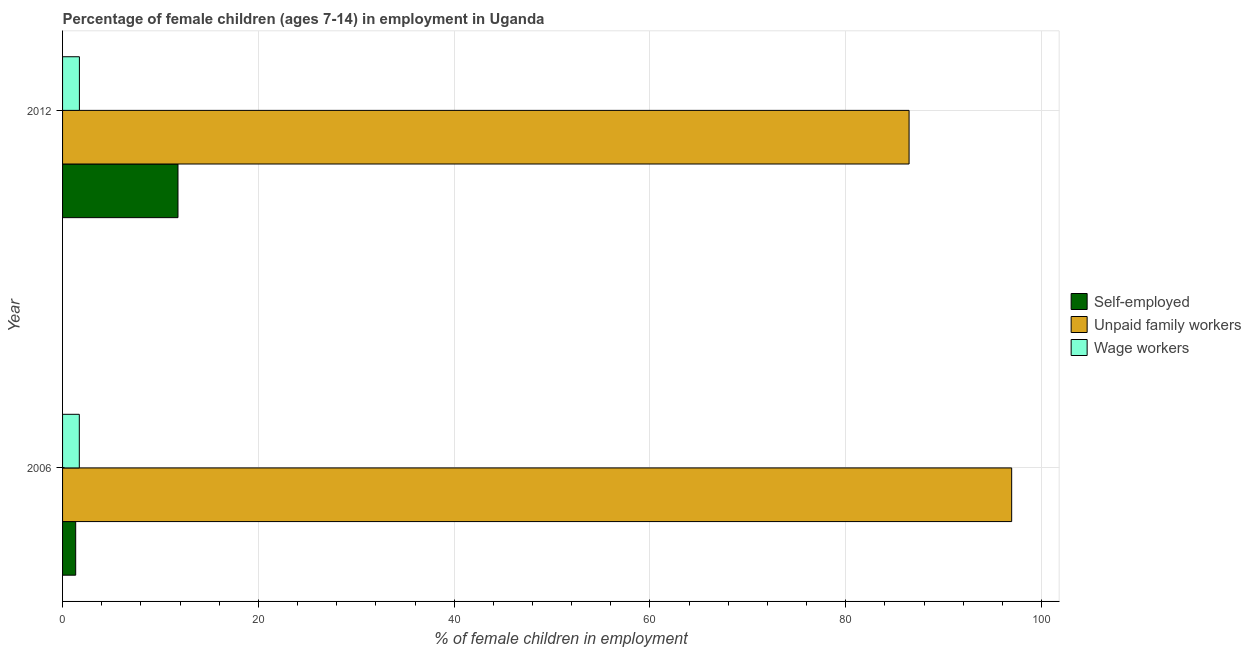Are the number of bars on each tick of the Y-axis equal?
Give a very brief answer. Yes. How many bars are there on the 1st tick from the bottom?
Offer a terse response. 3. What is the label of the 2nd group of bars from the top?
Provide a short and direct response. 2006. In how many cases, is the number of bars for a given year not equal to the number of legend labels?
Provide a short and direct response. 0. What is the percentage of children employed as wage workers in 2006?
Ensure brevity in your answer.  1.71. Across all years, what is the maximum percentage of children employed as wage workers?
Ensure brevity in your answer.  1.72. Across all years, what is the minimum percentage of children employed as wage workers?
Keep it short and to the point. 1.71. In which year was the percentage of children employed as unpaid family workers minimum?
Keep it short and to the point. 2012. What is the total percentage of self employed children in the graph?
Your answer should be very brief. 13.13. What is the difference between the percentage of children employed as unpaid family workers in 2006 and that in 2012?
Offer a terse response. 10.48. What is the difference between the percentage of children employed as unpaid family workers in 2006 and the percentage of children employed as wage workers in 2012?
Provide a succinct answer. 95.23. What is the average percentage of children employed as unpaid family workers per year?
Your answer should be compact. 91.71. In the year 2006, what is the difference between the percentage of self employed children and percentage of children employed as unpaid family workers?
Your answer should be compact. -95.61. In how many years, is the percentage of children employed as unpaid family workers greater than 4 %?
Offer a terse response. 2. What is the ratio of the percentage of self employed children in 2006 to that in 2012?
Provide a succinct answer. 0.11. What does the 1st bar from the top in 2012 represents?
Offer a terse response. Wage workers. What does the 3rd bar from the bottom in 2012 represents?
Ensure brevity in your answer.  Wage workers. Is it the case that in every year, the sum of the percentage of self employed children and percentage of children employed as unpaid family workers is greater than the percentage of children employed as wage workers?
Ensure brevity in your answer.  Yes. How many bars are there?
Provide a succinct answer. 6. Are all the bars in the graph horizontal?
Ensure brevity in your answer.  Yes. How many years are there in the graph?
Provide a succinct answer. 2. What is the difference between two consecutive major ticks on the X-axis?
Your response must be concise. 20. Are the values on the major ticks of X-axis written in scientific E-notation?
Provide a short and direct response. No. Does the graph contain grids?
Your answer should be compact. Yes. How many legend labels are there?
Your response must be concise. 3. How are the legend labels stacked?
Provide a short and direct response. Vertical. What is the title of the graph?
Offer a terse response. Percentage of female children (ages 7-14) in employment in Uganda. Does "Ages 15-64" appear as one of the legend labels in the graph?
Offer a very short reply. No. What is the label or title of the X-axis?
Your answer should be compact. % of female children in employment. What is the label or title of the Y-axis?
Give a very brief answer. Year. What is the % of female children in employment in Self-employed in 2006?
Offer a terse response. 1.34. What is the % of female children in employment of Unpaid family workers in 2006?
Give a very brief answer. 96.95. What is the % of female children in employment of Wage workers in 2006?
Make the answer very short. 1.71. What is the % of female children in employment of Self-employed in 2012?
Your response must be concise. 11.79. What is the % of female children in employment in Unpaid family workers in 2012?
Give a very brief answer. 86.47. What is the % of female children in employment in Wage workers in 2012?
Make the answer very short. 1.72. Across all years, what is the maximum % of female children in employment of Self-employed?
Offer a very short reply. 11.79. Across all years, what is the maximum % of female children in employment of Unpaid family workers?
Provide a short and direct response. 96.95. Across all years, what is the maximum % of female children in employment in Wage workers?
Make the answer very short. 1.72. Across all years, what is the minimum % of female children in employment of Self-employed?
Your answer should be very brief. 1.34. Across all years, what is the minimum % of female children in employment of Unpaid family workers?
Offer a very short reply. 86.47. Across all years, what is the minimum % of female children in employment in Wage workers?
Give a very brief answer. 1.71. What is the total % of female children in employment in Self-employed in the graph?
Your answer should be compact. 13.13. What is the total % of female children in employment in Unpaid family workers in the graph?
Offer a very short reply. 183.42. What is the total % of female children in employment in Wage workers in the graph?
Your answer should be very brief. 3.43. What is the difference between the % of female children in employment of Self-employed in 2006 and that in 2012?
Your answer should be very brief. -10.45. What is the difference between the % of female children in employment in Unpaid family workers in 2006 and that in 2012?
Offer a very short reply. 10.48. What is the difference between the % of female children in employment in Wage workers in 2006 and that in 2012?
Provide a succinct answer. -0.01. What is the difference between the % of female children in employment in Self-employed in 2006 and the % of female children in employment in Unpaid family workers in 2012?
Provide a short and direct response. -85.13. What is the difference between the % of female children in employment of Self-employed in 2006 and the % of female children in employment of Wage workers in 2012?
Provide a succinct answer. -0.38. What is the difference between the % of female children in employment in Unpaid family workers in 2006 and the % of female children in employment in Wage workers in 2012?
Keep it short and to the point. 95.23. What is the average % of female children in employment in Self-employed per year?
Make the answer very short. 6.57. What is the average % of female children in employment in Unpaid family workers per year?
Offer a very short reply. 91.71. What is the average % of female children in employment of Wage workers per year?
Make the answer very short. 1.72. In the year 2006, what is the difference between the % of female children in employment of Self-employed and % of female children in employment of Unpaid family workers?
Provide a short and direct response. -95.61. In the year 2006, what is the difference between the % of female children in employment in Self-employed and % of female children in employment in Wage workers?
Ensure brevity in your answer.  -0.37. In the year 2006, what is the difference between the % of female children in employment in Unpaid family workers and % of female children in employment in Wage workers?
Provide a short and direct response. 95.24. In the year 2012, what is the difference between the % of female children in employment of Self-employed and % of female children in employment of Unpaid family workers?
Offer a terse response. -74.68. In the year 2012, what is the difference between the % of female children in employment of Self-employed and % of female children in employment of Wage workers?
Offer a terse response. 10.07. In the year 2012, what is the difference between the % of female children in employment of Unpaid family workers and % of female children in employment of Wage workers?
Your answer should be very brief. 84.75. What is the ratio of the % of female children in employment of Self-employed in 2006 to that in 2012?
Offer a terse response. 0.11. What is the ratio of the % of female children in employment of Unpaid family workers in 2006 to that in 2012?
Offer a terse response. 1.12. What is the difference between the highest and the second highest % of female children in employment of Self-employed?
Ensure brevity in your answer.  10.45. What is the difference between the highest and the second highest % of female children in employment of Unpaid family workers?
Give a very brief answer. 10.48. What is the difference between the highest and the second highest % of female children in employment of Wage workers?
Keep it short and to the point. 0.01. What is the difference between the highest and the lowest % of female children in employment in Self-employed?
Keep it short and to the point. 10.45. What is the difference between the highest and the lowest % of female children in employment in Unpaid family workers?
Make the answer very short. 10.48. 